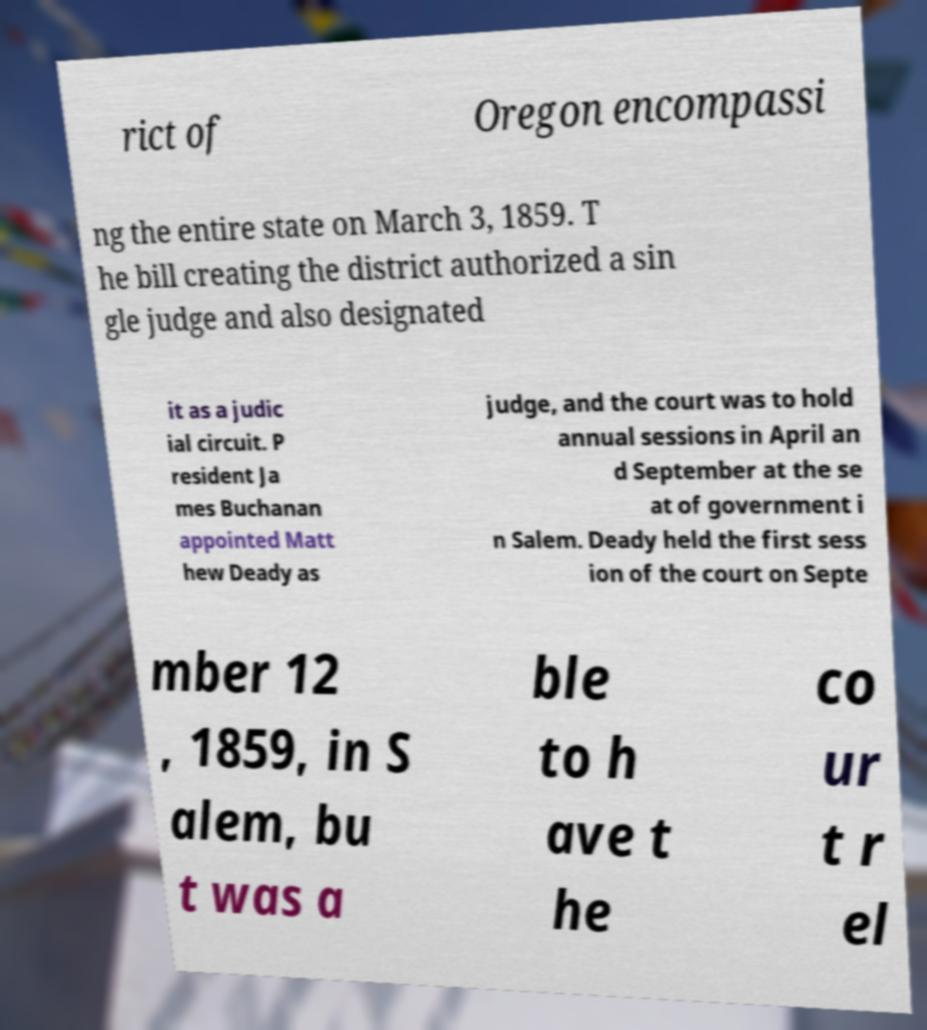Please read and relay the text visible in this image. What does it say? rict of Oregon encompassi ng the entire state on March 3, 1859. T he bill creating the district authorized a sin gle judge and also designated it as a judic ial circuit. P resident Ja mes Buchanan appointed Matt hew Deady as judge, and the court was to hold annual sessions in April an d September at the se at of government i n Salem. Deady held the first sess ion of the court on Septe mber 12 , 1859, in S alem, bu t was a ble to h ave t he co ur t r el 